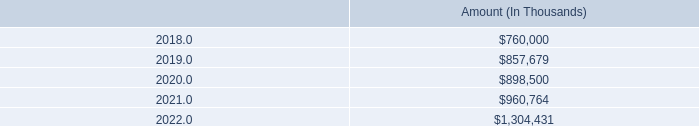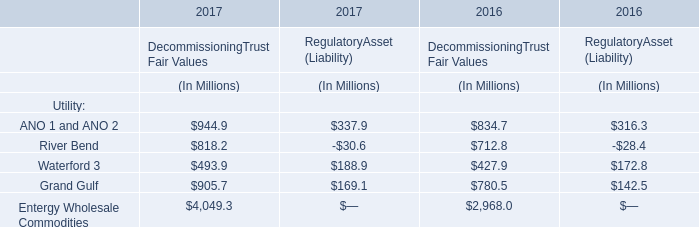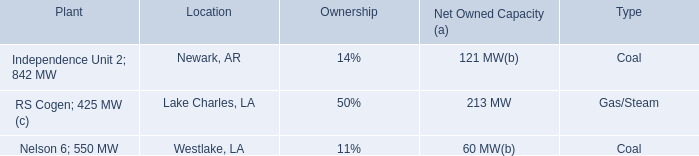What is the ratio of ANO 1 and ANO 2 to the total in 2017 for DecommissioningTrust Fair Values? 
Computations: (944.9 / ((((944.9 + 818.2) + 493.9) + 905.7) + 4049.3))
Answer: 0.13102. What is the difference between the greatest ANO 1 and ANO 2 in 2016 and 2017? (in Million) 
Computations: ((944.9 + 337.9) - (834.7 + 316.3))
Answer: 131.8. 